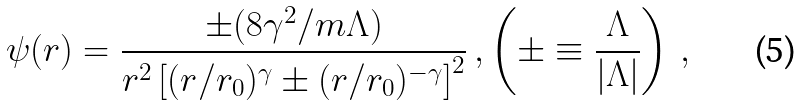<formula> <loc_0><loc_0><loc_500><loc_500>\psi ( r ) = \frac { \pm ( { 8 \gamma ^ { 2 } } / { m \Lambda } ) } { r ^ { 2 } \left [ ( { r } / { r _ { 0 } } ) ^ { \gamma } \pm ( { r } / { r _ { 0 } } ) ^ { - \gamma } \right ] ^ { 2 } } \, , \left ( \pm \equiv \frac { \Lambda } { | \Lambda | } \right ) \, ,</formula> 